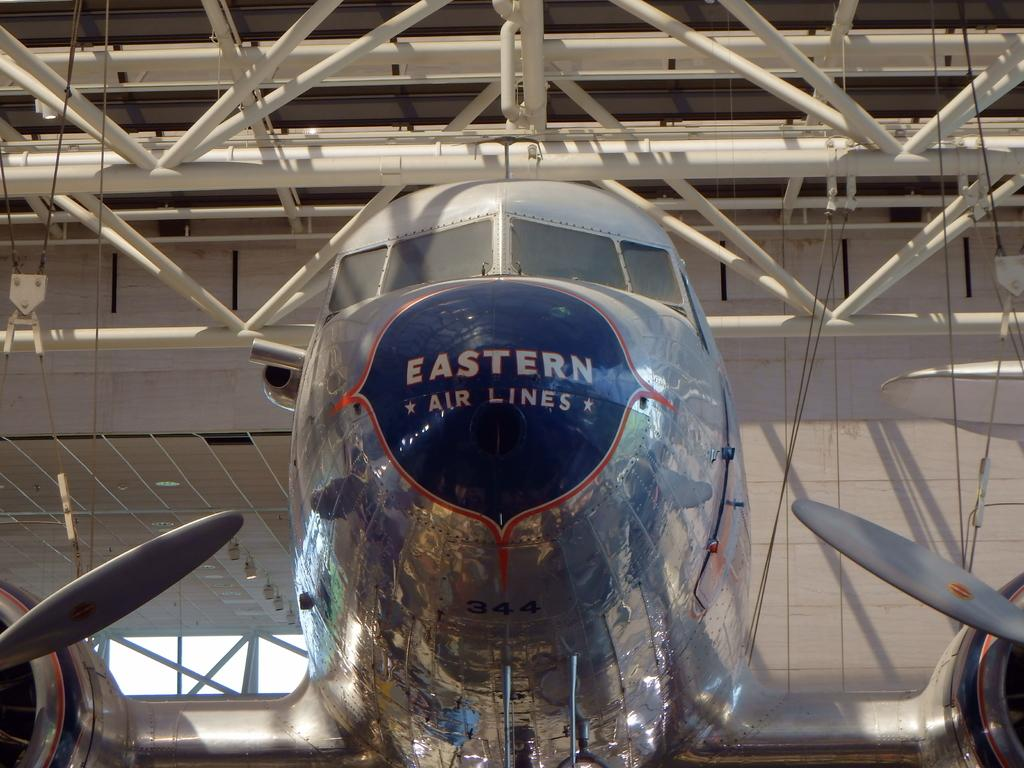<image>
Write a terse but informative summary of the picture. A front on image of an Easter Airlines prop Jet in an aircraft hangar. 